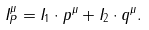<formula> <loc_0><loc_0><loc_500><loc_500>I ^ { \mu } _ { P } = I _ { 1 } \cdot p ^ { \mu } + I _ { 2 } \cdot q ^ { \mu } .</formula> 